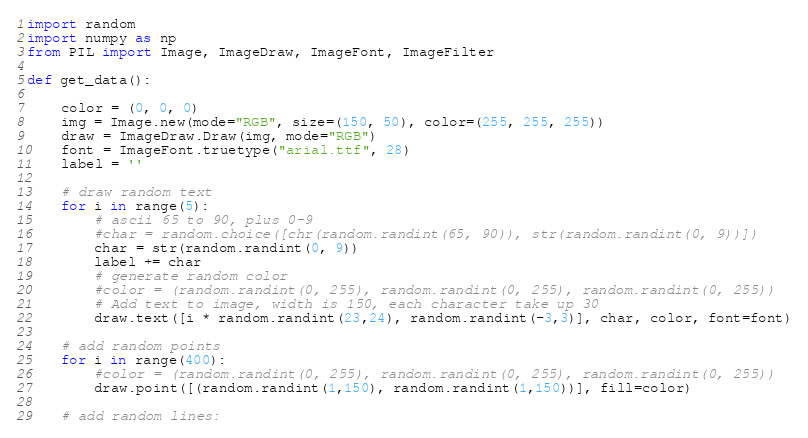Convert code to text. <code><loc_0><loc_0><loc_500><loc_500><_Python_>import random
import numpy as np
from PIL import Image, ImageDraw, ImageFont, ImageFilter

def get_data():

    color = (0, 0, 0)
    img = Image.new(mode="RGB", size=(150, 50), color=(255, 255, 255))
    draw = ImageDraw.Draw(img, mode="RGB")
    font = ImageFont.truetype("arial.ttf", 28)
    label = ''

    # draw random text
    for i in range(5):
        # ascii 65 to 90, plus 0-9
        #char = random.choice([chr(random.randint(65, 90)), str(random.randint(0, 9))])
        char = str(random.randint(0, 9))
        label += char
        # generate random color
        #color = (random.randint(0, 255), random.randint(0, 255), random.randint(0, 255))
        # Add text to image, width is 150, each character take up 30
        draw.text([i * random.randint(23,24), random.randint(-3,3)], char, color, font=font)

    # add random points
    for i in range(400):
        #color = (random.randint(0, 255), random.randint(0, 255), random.randint(0, 255))
        draw.point([(random.randint(1,150), random.randint(1,150))], fill=color)

    # add random lines:</code> 